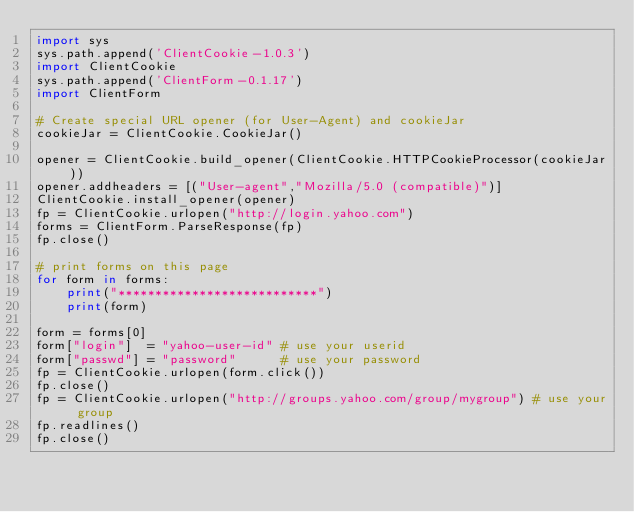<code> <loc_0><loc_0><loc_500><loc_500><_Python_>import sys
sys.path.append('ClientCookie-1.0.3')
import ClientCookie
sys.path.append('ClientForm-0.1.17')
import ClientForm

# Create special URL opener (for User-Agent) and cookieJar
cookieJar = ClientCookie.CookieJar()

opener = ClientCookie.build_opener(ClientCookie.HTTPCookieProcessor(cookieJar))
opener.addheaders = [("User-agent","Mozilla/5.0 (compatible)")]
ClientCookie.install_opener(opener)
fp = ClientCookie.urlopen("http://login.yahoo.com")
forms = ClientForm.ParseResponse(fp)
fp.close()

# print forms on this page
for form in forms: 
    print("***************************")
    print(form)

form = forms[0]
form["login"]  = "yahoo-user-id" # use your userid
form["passwd"] = "password"      # use your password
fp = ClientCookie.urlopen(form.click())
fp.close()
fp = ClientCookie.urlopen("http://groups.yahoo.com/group/mygroup") # use your group
fp.readlines()
fp.close()
</code> 